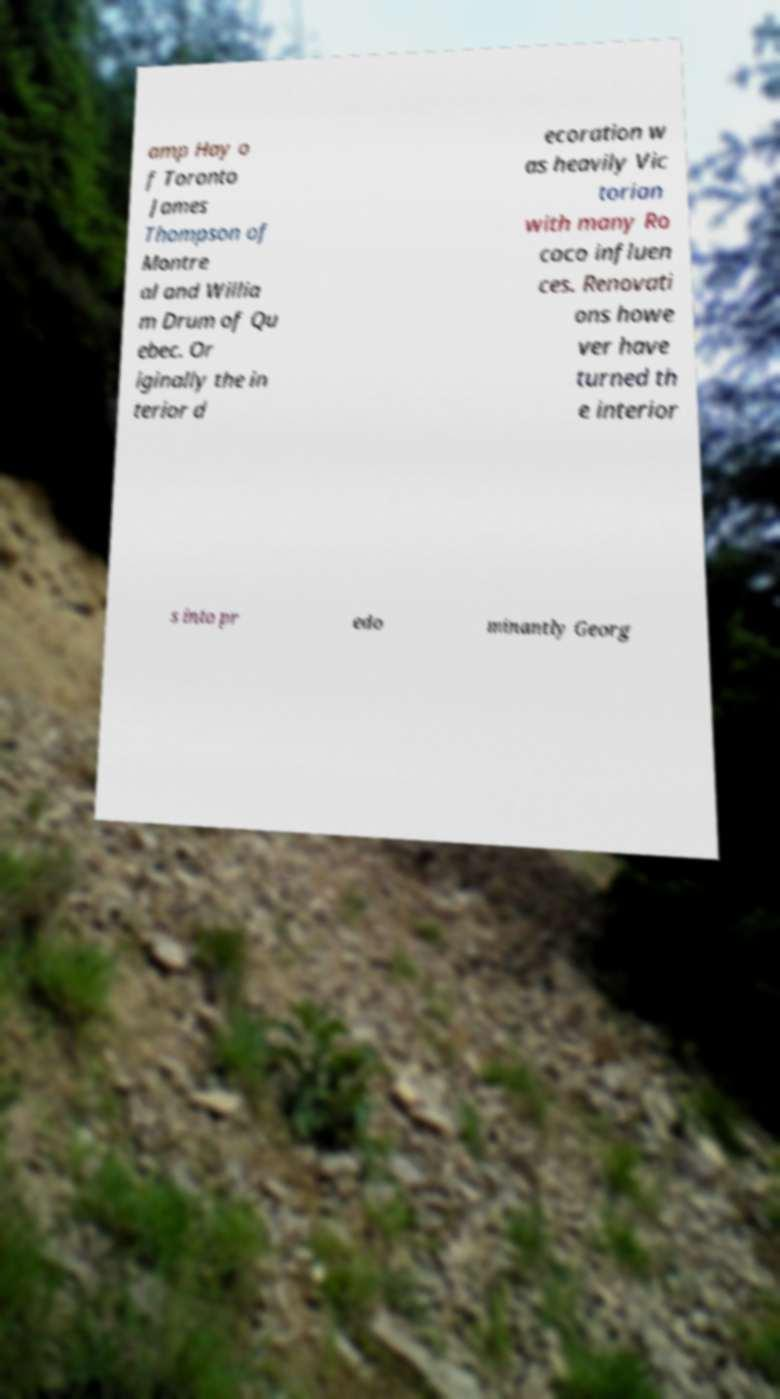What messages or text are displayed in this image? I need them in a readable, typed format. amp Hay o f Toronto James Thompson of Montre al and Willia m Drum of Qu ebec. Or iginally the in terior d ecoration w as heavily Vic torian with many Ro coco influen ces. Renovati ons howe ver have turned th e interior s into pr edo minantly Georg 